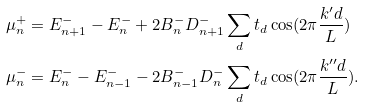Convert formula to latex. <formula><loc_0><loc_0><loc_500><loc_500>\mu ^ { + } _ { n } & = E ^ { - } _ { n + 1 } - E ^ { - } _ { n } + 2 B ^ { - } _ { n } D ^ { - } _ { n + 1 } \sum _ { d } t _ { d } \cos ( 2 \pi \frac { k ^ { \prime } d } L ) \\ \mu ^ { - } _ { n } & = E ^ { - } _ { n } - E ^ { - } _ { n - 1 } - 2 B ^ { - } _ { n - 1 } D ^ { - } _ { n } \sum _ { d } t _ { d } \cos ( 2 \pi \frac { k ^ { \prime \prime } d } L ) .</formula> 